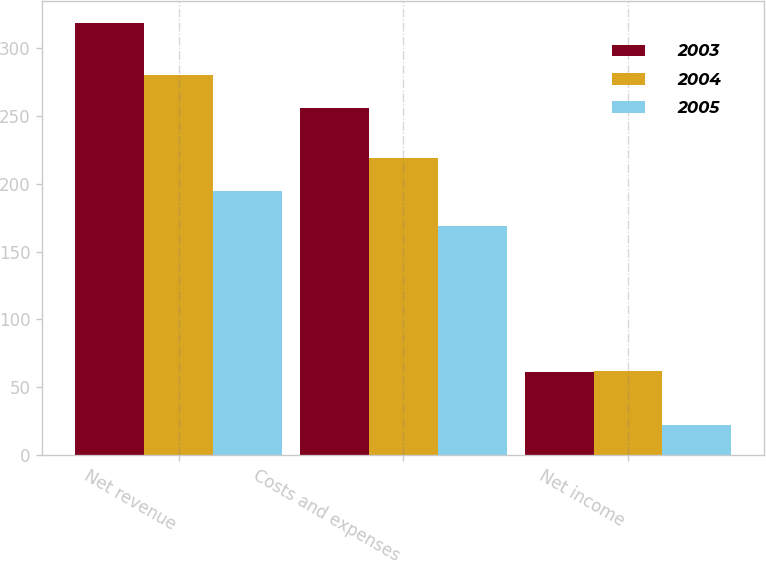Convert chart. <chart><loc_0><loc_0><loc_500><loc_500><stacked_bar_chart><ecel><fcel>Net revenue<fcel>Costs and expenses<fcel>Net income<nl><fcel>2003<fcel>319<fcel>256<fcel>61<nl><fcel>2004<fcel>280<fcel>219<fcel>62<nl><fcel>2005<fcel>195<fcel>169<fcel>22<nl></chart> 